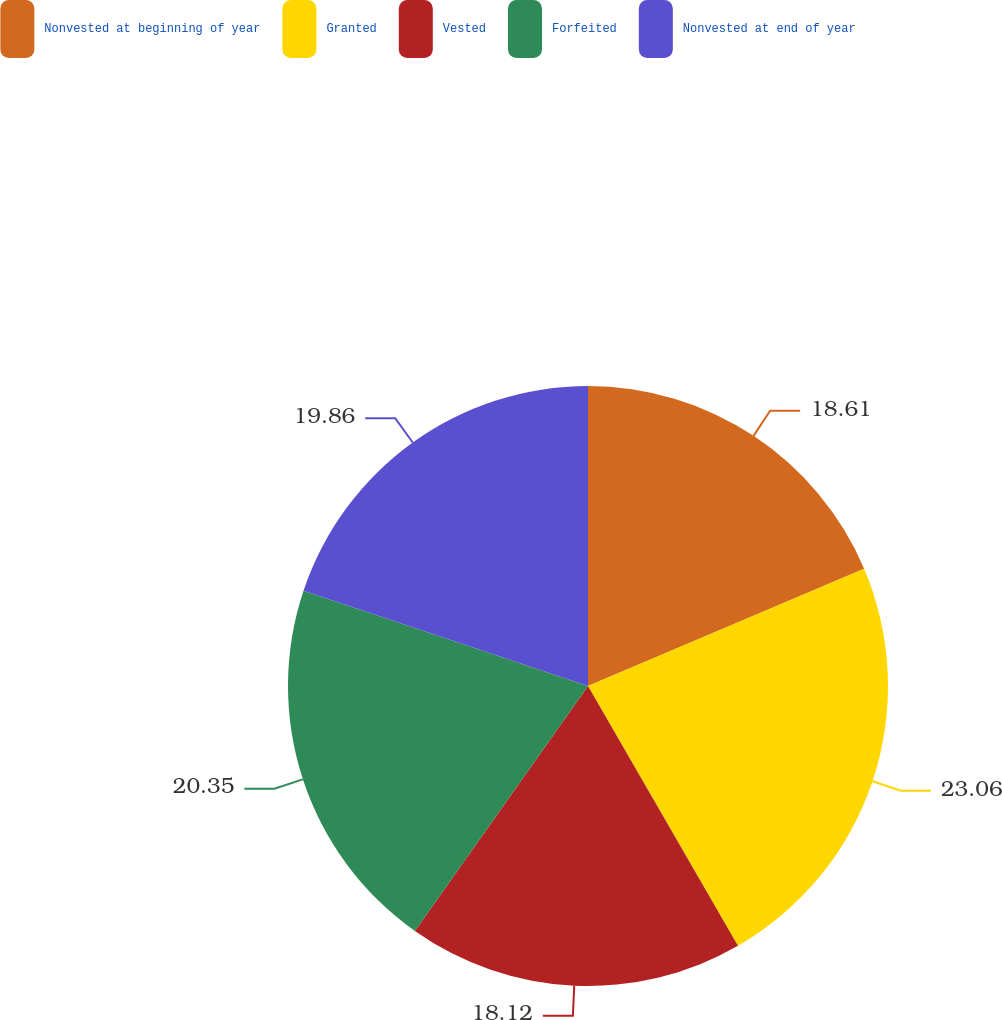<chart> <loc_0><loc_0><loc_500><loc_500><pie_chart><fcel>Nonvested at beginning of year<fcel>Granted<fcel>Vested<fcel>Forfeited<fcel>Nonvested at end of year<nl><fcel>18.61%<fcel>23.06%<fcel>18.12%<fcel>20.35%<fcel>19.86%<nl></chart> 